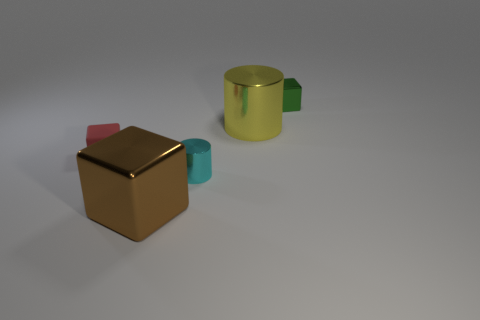Add 4 cyan blocks. How many objects exist? 9 Subtract all blocks. How many objects are left? 2 Subtract 1 green cubes. How many objects are left? 4 Subtract all tiny gray metal things. Subtract all big cubes. How many objects are left? 4 Add 4 large yellow shiny cylinders. How many large yellow shiny cylinders are left? 5 Add 3 small green shiny spheres. How many small green shiny spheres exist? 3 